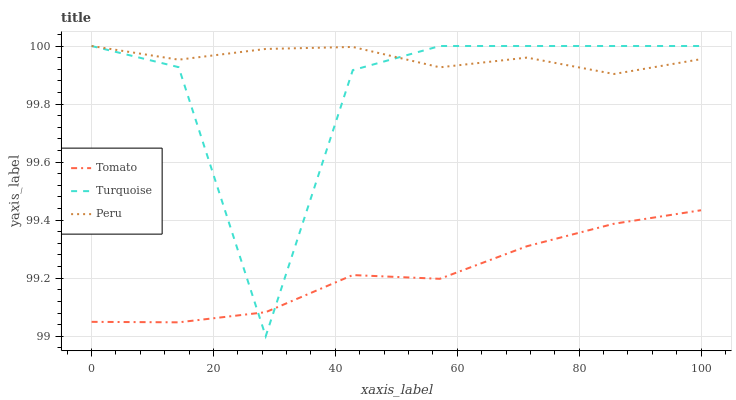Does Tomato have the minimum area under the curve?
Answer yes or no. Yes. Does Peru have the maximum area under the curve?
Answer yes or no. Yes. Does Turquoise have the minimum area under the curve?
Answer yes or no. No. Does Turquoise have the maximum area under the curve?
Answer yes or no. No. Is Tomato the smoothest?
Answer yes or no. Yes. Is Turquoise the roughest?
Answer yes or no. Yes. Is Peru the smoothest?
Answer yes or no. No. Is Peru the roughest?
Answer yes or no. No. Does Turquoise have the lowest value?
Answer yes or no. Yes. Does Peru have the lowest value?
Answer yes or no. No. Does Peru have the highest value?
Answer yes or no. Yes. Is Tomato less than Peru?
Answer yes or no. Yes. Is Peru greater than Tomato?
Answer yes or no. Yes. Does Turquoise intersect Peru?
Answer yes or no. Yes. Is Turquoise less than Peru?
Answer yes or no. No. Is Turquoise greater than Peru?
Answer yes or no. No. Does Tomato intersect Peru?
Answer yes or no. No. 